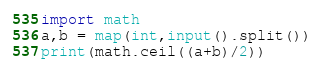<code> <loc_0><loc_0><loc_500><loc_500><_Python_>import math
a,b = map(int,input().split())
print(math.ceil((a+b)/2))</code> 